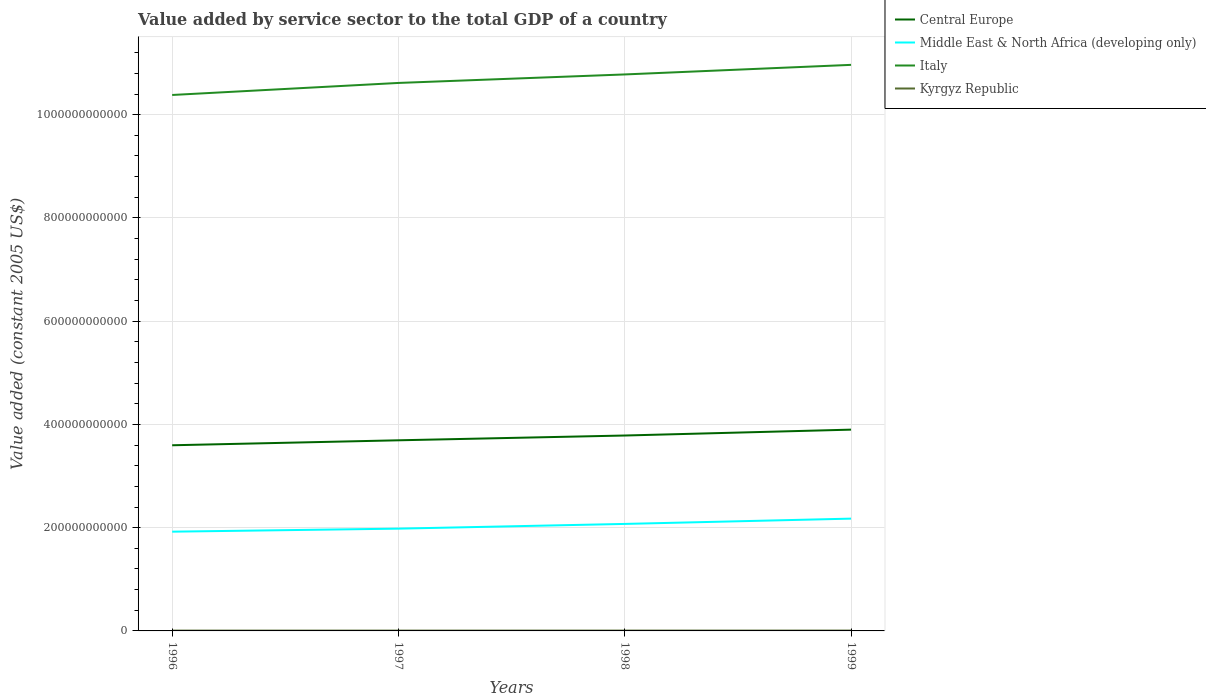Does the line corresponding to Middle East & North Africa (developing only) intersect with the line corresponding to Kyrgyz Republic?
Keep it short and to the point. No. Across all years, what is the maximum value added by service sector in Central Europe?
Keep it short and to the point. 3.60e+11. In which year was the value added by service sector in Italy maximum?
Provide a succinct answer. 1996. What is the total value added by service sector in Kyrgyz Republic in the graph?
Make the answer very short. -2.16e+07. What is the difference between the highest and the second highest value added by service sector in Kyrgyz Republic?
Your response must be concise. 4.91e+07. Is the value added by service sector in Italy strictly greater than the value added by service sector in Middle East & North Africa (developing only) over the years?
Provide a short and direct response. No. What is the difference between two consecutive major ticks on the Y-axis?
Provide a short and direct response. 2.00e+11. How many legend labels are there?
Keep it short and to the point. 4. How are the legend labels stacked?
Your answer should be compact. Vertical. What is the title of the graph?
Your answer should be very brief. Value added by service sector to the total GDP of a country. What is the label or title of the Y-axis?
Your answer should be very brief. Value added (constant 2005 US$). What is the Value added (constant 2005 US$) in Central Europe in 1996?
Your response must be concise. 3.60e+11. What is the Value added (constant 2005 US$) of Middle East & North Africa (developing only) in 1996?
Your answer should be compact. 1.92e+11. What is the Value added (constant 2005 US$) of Italy in 1996?
Provide a short and direct response. 1.04e+12. What is the Value added (constant 2005 US$) in Kyrgyz Republic in 1996?
Make the answer very short. 6.12e+08. What is the Value added (constant 2005 US$) of Central Europe in 1997?
Keep it short and to the point. 3.69e+11. What is the Value added (constant 2005 US$) in Middle East & North Africa (developing only) in 1997?
Your answer should be very brief. 1.98e+11. What is the Value added (constant 2005 US$) in Italy in 1997?
Your answer should be very brief. 1.06e+12. What is the Value added (constant 2005 US$) in Kyrgyz Republic in 1997?
Offer a very short reply. 6.16e+08. What is the Value added (constant 2005 US$) of Central Europe in 1998?
Your answer should be compact. 3.78e+11. What is the Value added (constant 2005 US$) in Middle East & North Africa (developing only) in 1998?
Your response must be concise. 2.07e+11. What is the Value added (constant 2005 US$) in Italy in 1998?
Offer a terse response. 1.08e+12. What is the Value added (constant 2005 US$) in Kyrgyz Republic in 1998?
Your answer should be compact. 6.40e+08. What is the Value added (constant 2005 US$) in Central Europe in 1999?
Make the answer very short. 3.90e+11. What is the Value added (constant 2005 US$) of Middle East & North Africa (developing only) in 1999?
Give a very brief answer. 2.18e+11. What is the Value added (constant 2005 US$) of Italy in 1999?
Offer a terse response. 1.10e+12. What is the Value added (constant 2005 US$) of Kyrgyz Republic in 1999?
Provide a short and direct response. 6.61e+08. Across all years, what is the maximum Value added (constant 2005 US$) of Central Europe?
Ensure brevity in your answer.  3.90e+11. Across all years, what is the maximum Value added (constant 2005 US$) of Middle East & North Africa (developing only)?
Offer a terse response. 2.18e+11. Across all years, what is the maximum Value added (constant 2005 US$) in Italy?
Give a very brief answer. 1.10e+12. Across all years, what is the maximum Value added (constant 2005 US$) in Kyrgyz Republic?
Make the answer very short. 6.61e+08. Across all years, what is the minimum Value added (constant 2005 US$) in Central Europe?
Your answer should be very brief. 3.60e+11. Across all years, what is the minimum Value added (constant 2005 US$) of Middle East & North Africa (developing only)?
Keep it short and to the point. 1.92e+11. Across all years, what is the minimum Value added (constant 2005 US$) in Italy?
Make the answer very short. 1.04e+12. Across all years, what is the minimum Value added (constant 2005 US$) of Kyrgyz Republic?
Provide a succinct answer. 6.12e+08. What is the total Value added (constant 2005 US$) in Central Europe in the graph?
Your response must be concise. 1.50e+12. What is the total Value added (constant 2005 US$) in Middle East & North Africa (developing only) in the graph?
Your answer should be compact. 8.15e+11. What is the total Value added (constant 2005 US$) in Italy in the graph?
Offer a terse response. 4.27e+12. What is the total Value added (constant 2005 US$) in Kyrgyz Republic in the graph?
Offer a terse response. 2.53e+09. What is the difference between the Value added (constant 2005 US$) in Central Europe in 1996 and that in 1997?
Provide a succinct answer. -9.62e+09. What is the difference between the Value added (constant 2005 US$) of Middle East & North Africa (developing only) in 1996 and that in 1997?
Your answer should be very brief. -5.87e+09. What is the difference between the Value added (constant 2005 US$) of Italy in 1996 and that in 1997?
Provide a succinct answer. -2.33e+1. What is the difference between the Value added (constant 2005 US$) in Kyrgyz Republic in 1996 and that in 1997?
Your response must be concise. -3.77e+06. What is the difference between the Value added (constant 2005 US$) of Central Europe in 1996 and that in 1998?
Offer a very short reply. -1.89e+1. What is the difference between the Value added (constant 2005 US$) in Middle East & North Africa (developing only) in 1996 and that in 1998?
Ensure brevity in your answer.  -1.50e+1. What is the difference between the Value added (constant 2005 US$) in Italy in 1996 and that in 1998?
Your response must be concise. -3.98e+1. What is the difference between the Value added (constant 2005 US$) of Kyrgyz Republic in 1996 and that in 1998?
Offer a terse response. -2.76e+07. What is the difference between the Value added (constant 2005 US$) in Central Europe in 1996 and that in 1999?
Provide a succinct answer. -3.02e+1. What is the difference between the Value added (constant 2005 US$) of Middle East & North Africa (developing only) in 1996 and that in 1999?
Make the answer very short. -2.52e+1. What is the difference between the Value added (constant 2005 US$) in Italy in 1996 and that in 1999?
Keep it short and to the point. -5.83e+1. What is the difference between the Value added (constant 2005 US$) in Kyrgyz Republic in 1996 and that in 1999?
Offer a terse response. -4.91e+07. What is the difference between the Value added (constant 2005 US$) of Central Europe in 1997 and that in 1998?
Your answer should be very brief. -9.24e+09. What is the difference between the Value added (constant 2005 US$) in Middle East & North Africa (developing only) in 1997 and that in 1998?
Offer a terse response. -9.13e+09. What is the difference between the Value added (constant 2005 US$) of Italy in 1997 and that in 1998?
Offer a terse response. -1.65e+1. What is the difference between the Value added (constant 2005 US$) in Kyrgyz Republic in 1997 and that in 1998?
Keep it short and to the point. -2.38e+07. What is the difference between the Value added (constant 2005 US$) of Central Europe in 1997 and that in 1999?
Provide a short and direct response. -2.06e+1. What is the difference between the Value added (constant 2005 US$) of Middle East & North Africa (developing only) in 1997 and that in 1999?
Your response must be concise. -1.94e+1. What is the difference between the Value added (constant 2005 US$) of Italy in 1997 and that in 1999?
Give a very brief answer. -3.50e+1. What is the difference between the Value added (constant 2005 US$) in Kyrgyz Republic in 1997 and that in 1999?
Provide a short and direct response. -4.54e+07. What is the difference between the Value added (constant 2005 US$) of Central Europe in 1998 and that in 1999?
Keep it short and to the point. -1.14e+1. What is the difference between the Value added (constant 2005 US$) of Middle East & North Africa (developing only) in 1998 and that in 1999?
Offer a very short reply. -1.03e+1. What is the difference between the Value added (constant 2005 US$) of Italy in 1998 and that in 1999?
Offer a very short reply. -1.85e+1. What is the difference between the Value added (constant 2005 US$) in Kyrgyz Republic in 1998 and that in 1999?
Offer a very short reply. -2.16e+07. What is the difference between the Value added (constant 2005 US$) of Central Europe in 1996 and the Value added (constant 2005 US$) of Middle East & North Africa (developing only) in 1997?
Offer a terse response. 1.61e+11. What is the difference between the Value added (constant 2005 US$) in Central Europe in 1996 and the Value added (constant 2005 US$) in Italy in 1997?
Your answer should be compact. -7.02e+11. What is the difference between the Value added (constant 2005 US$) of Central Europe in 1996 and the Value added (constant 2005 US$) of Kyrgyz Republic in 1997?
Provide a succinct answer. 3.59e+11. What is the difference between the Value added (constant 2005 US$) in Middle East & North Africa (developing only) in 1996 and the Value added (constant 2005 US$) in Italy in 1997?
Ensure brevity in your answer.  -8.69e+11. What is the difference between the Value added (constant 2005 US$) of Middle East & North Africa (developing only) in 1996 and the Value added (constant 2005 US$) of Kyrgyz Republic in 1997?
Make the answer very short. 1.92e+11. What is the difference between the Value added (constant 2005 US$) in Italy in 1996 and the Value added (constant 2005 US$) in Kyrgyz Republic in 1997?
Provide a succinct answer. 1.04e+12. What is the difference between the Value added (constant 2005 US$) of Central Europe in 1996 and the Value added (constant 2005 US$) of Middle East & North Africa (developing only) in 1998?
Your answer should be very brief. 1.52e+11. What is the difference between the Value added (constant 2005 US$) in Central Europe in 1996 and the Value added (constant 2005 US$) in Italy in 1998?
Make the answer very short. -7.18e+11. What is the difference between the Value added (constant 2005 US$) of Central Europe in 1996 and the Value added (constant 2005 US$) of Kyrgyz Republic in 1998?
Provide a short and direct response. 3.59e+11. What is the difference between the Value added (constant 2005 US$) of Middle East & North Africa (developing only) in 1996 and the Value added (constant 2005 US$) of Italy in 1998?
Provide a short and direct response. -8.86e+11. What is the difference between the Value added (constant 2005 US$) in Middle East & North Africa (developing only) in 1996 and the Value added (constant 2005 US$) in Kyrgyz Republic in 1998?
Give a very brief answer. 1.92e+11. What is the difference between the Value added (constant 2005 US$) of Italy in 1996 and the Value added (constant 2005 US$) of Kyrgyz Republic in 1998?
Your answer should be compact. 1.04e+12. What is the difference between the Value added (constant 2005 US$) of Central Europe in 1996 and the Value added (constant 2005 US$) of Middle East & North Africa (developing only) in 1999?
Make the answer very short. 1.42e+11. What is the difference between the Value added (constant 2005 US$) in Central Europe in 1996 and the Value added (constant 2005 US$) in Italy in 1999?
Make the answer very short. -7.37e+11. What is the difference between the Value added (constant 2005 US$) in Central Europe in 1996 and the Value added (constant 2005 US$) in Kyrgyz Republic in 1999?
Your answer should be compact. 3.59e+11. What is the difference between the Value added (constant 2005 US$) of Middle East & North Africa (developing only) in 1996 and the Value added (constant 2005 US$) of Italy in 1999?
Make the answer very short. -9.04e+11. What is the difference between the Value added (constant 2005 US$) of Middle East & North Africa (developing only) in 1996 and the Value added (constant 2005 US$) of Kyrgyz Republic in 1999?
Your answer should be very brief. 1.92e+11. What is the difference between the Value added (constant 2005 US$) in Italy in 1996 and the Value added (constant 2005 US$) in Kyrgyz Republic in 1999?
Your answer should be very brief. 1.04e+12. What is the difference between the Value added (constant 2005 US$) in Central Europe in 1997 and the Value added (constant 2005 US$) in Middle East & North Africa (developing only) in 1998?
Keep it short and to the point. 1.62e+11. What is the difference between the Value added (constant 2005 US$) in Central Europe in 1997 and the Value added (constant 2005 US$) in Italy in 1998?
Offer a very short reply. -7.09e+11. What is the difference between the Value added (constant 2005 US$) in Central Europe in 1997 and the Value added (constant 2005 US$) in Kyrgyz Republic in 1998?
Your response must be concise. 3.69e+11. What is the difference between the Value added (constant 2005 US$) of Middle East & North Africa (developing only) in 1997 and the Value added (constant 2005 US$) of Italy in 1998?
Your answer should be very brief. -8.80e+11. What is the difference between the Value added (constant 2005 US$) in Middle East & North Africa (developing only) in 1997 and the Value added (constant 2005 US$) in Kyrgyz Republic in 1998?
Ensure brevity in your answer.  1.97e+11. What is the difference between the Value added (constant 2005 US$) of Italy in 1997 and the Value added (constant 2005 US$) of Kyrgyz Republic in 1998?
Your answer should be very brief. 1.06e+12. What is the difference between the Value added (constant 2005 US$) in Central Europe in 1997 and the Value added (constant 2005 US$) in Middle East & North Africa (developing only) in 1999?
Ensure brevity in your answer.  1.52e+11. What is the difference between the Value added (constant 2005 US$) in Central Europe in 1997 and the Value added (constant 2005 US$) in Italy in 1999?
Ensure brevity in your answer.  -7.27e+11. What is the difference between the Value added (constant 2005 US$) in Central Europe in 1997 and the Value added (constant 2005 US$) in Kyrgyz Republic in 1999?
Your response must be concise. 3.69e+11. What is the difference between the Value added (constant 2005 US$) in Middle East & North Africa (developing only) in 1997 and the Value added (constant 2005 US$) in Italy in 1999?
Offer a terse response. -8.98e+11. What is the difference between the Value added (constant 2005 US$) in Middle East & North Africa (developing only) in 1997 and the Value added (constant 2005 US$) in Kyrgyz Republic in 1999?
Your answer should be very brief. 1.97e+11. What is the difference between the Value added (constant 2005 US$) in Italy in 1997 and the Value added (constant 2005 US$) in Kyrgyz Republic in 1999?
Your response must be concise. 1.06e+12. What is the difference between the Value added (constant 2005 US$) of Central Europe in 1998 and the Value added (constant 2005 US$) of Middle East & North Africa (developing only) in 1999?
Provide a succinct answer. 1.61e+11. What is the difference between the Value added (constant 2005 US$) in Central Europe in 1998 and the Value added (constant 2005 US$) in Italy in 1999?
Ensure brevity in your answer.  -7.18e+11. What is the difference between the Value added (constant 2005 US$) of Central Europe in 1998 and the Value added (constant 2005 US$) of Kyrgyz Republic in 1999?
Give a very brief answer. 3.78e+11. What is the difference between the Value added (constant 2005 US$) of Middle East & North Africa (developing only) in 1998 and the Value added (constant 2005 US$) of Italy in 1999?
Your answer should be compact. -8.89e+11. What is the difference between the Value added (constant 2005 US$) of Middle East & North Africa (developing only) in 1998 and the Value added (constant 2005 US$) of Kyrgyz Republic in 1999?
Provide a short and direct response. 2.07e+11. What is the difference between the Value added (constant 2005 US$) of Italy in 1998 and the Value added (constant 2005 US$) of Kyrgyz Republic in 1999?
Give a very brief answer. 1.08e+12. What is the average Value added (constant 2005 US$) in Central Europe per year?
Make the answer very short. 3.74e+11. What is the average Value added (constant 2005 US$) in Middle East & North Africa (developing only) per year?
Provide a short and direct response. 2.04e+11. What is the average Value added (constant 2005 US$) of Italy per year?
Offer a very short reply. 1.07e+12. What is the average Value added (constant 2005 US$) in Kyrgyz Republic per year?
Your answer should be compact. 6.32e+08. In the year 1996, what is the difference between the Value added (constant 2005 US$) of Central Europe and Value added (constant 2005 US$) of Middle East & North Africa (developing only)?
Your answer should be very brief. 1.67e+11. In the year 1996, what is the difference between the Value added (constant 2005 US$) of Central Europe and Value added (constant 2005 US$) of Italy?
Your response must be concise. -6.78e+11. In the year 1996, what is the difference between the Value added (constant 2005 US$) of Central Europe and Value added (constant 2005 US$) of Kyrgyz Republic?
Your answer should be compact. 3.59e+11. In the year 1996, what is the difference between the Value added (constant 2005 US$) of Middle East & North Africa (developing only) and Value added (constant 2005 US$) of Italy?
Your answer should be compact. -8.46e+11. In the year 1996, what is the difference between the Value added (constant 2005 US$) in Middle East & North Africa (developing only) and Value added (constant 2005 US$) in Kyrgyz Republic?
Offer a terse response. 1.92e+11. In the year 1996, what is the difference between the Value added (constant 2005 US$) of Italy and Value added (constant 2005 US$) of Kyrgyz Republic?
Make the answer very short. 1.04e+12. In the year 1997, what is the difference between the Value added (constant 2005 US$) of Central Europe and Value added (constant 2005 US$) of Middle East & North Africa (developing only)?
Offer a terse response. 1.71e+11. In the year 1997, what is the difference between the Value added (constant 2005 US$) of Central Europe and Value added (constant 2005 US$) of Italy?
Make the answer very short. -6.92e+11. In the year 1997, what is the difference between the Value added (constant 2005 US$) of Central Europe and Value added (constant 2005 US$) of Kyrgyz Republic?
Make the answer very short. 3.69e+11. In the year 1997, what is the difference between the Value added (constant 2005 US$) of Middle East & North Africa (developing only) and Value added (constant 2005 US$) of Italy?
Keep it short and to the point. -8.63e+11. In the year 1997, what is the difference between the Value added (constant 2005 US$) in Middle East & North Africa (developing only) and Value added (constant 2005 US$) in Kyrgyz Republic?
Give a very brief answer. 1.98e+11. In the year 1997, what is the difference between the Value added (constant 2005 US$) of Italy and Value added (constant 2005 US$) of Kyrgyz Republic?
Provide a short and direct response. 1.06e+12. In the year 1998, what is the difference between the Value added (constant 2005 US$) in Central Europe and Value added (constant 2005 US$) in Middle East & North Africa (developing only)?
Your answer should be very brief. 1.71e+11. In the year 1998, what is the difference between the Value added (constant 2005 US$) of Central Europe and Value added (constant 2005 US$) of Italy?
Ensure brevity in your answer.  -6.99e+11. In the year 1998, what is the difference between the Value added (constant 2005 US$) in Central Europe and Value added (constant 2005 US$) in Kyrgyz Republic?
Your answer should be very brief. 3.78e+11. In the year 1998, what is the difference between the Value added (constant 2005 US$) in Middle East & North Africa (developing only) and Value added (constant 2005 US$) in Italy?
Your answer should be compact. -8.71e+11. In the year 1998, what is the difference between the Value added (constant 2005 US$) in Middle East & North Africa (developing only) and Value added (constant 2005 US$) in Kyrgyz Republic?
Keep it short and to the point. 2.07e+11. In the year 1998, what is the difference between the Value added (constant 2005 US$) of Italy and Value added (constant 2005 US$) of Kyrgyz Republic?
Keep it short and to the point. 1.08e+12. In the year 1999, what is the difference between the Value added (constant 2005 US$) of Central Europe and Value added (constant 2005 US$) of Middle East & North Africa (developing only)?
Your answer should be compact. 1.72e+11. In the year 1999, what is the difference between the Value added (constant 2005 US$) in Central Europe and Value added (constant 2005 US$) in Italy?
Ensure brevity in your answer.  -7.07e+11. In the year 1999, what is the difference between the Value added (constant 2005 US$) of Central Europe and Value added (constant 2005 US$) of Kyrgyz Republic?
Offer a terse response. 3.89e+11. In the year 1999, what is the difference between the Value added (constant 2005 US$) in Middle East & North Africa (developing only) and Value added (constant 2005 US$) in Italy?
Offer a terse response. -8.79e+11. In the year 1999, what is the difference between the Value added (constant 2005 US$) of Middle East & North Africa (developing only) and Value added (constant 2005 US$) of Kyrgyz Republic?
Offer a terse response. 2.17e+11. In the year 1999, what is the difference between the Value added (constant 2005 US$) of Italy and Value added (constant 2005 US$) of Kyrgyz Republic?
Offer a very short reply. 1.10e+12. What is the ratio of the Value added (constant 2005 US$) of Central Europe in 1996 to that in 1997?
Your response must be concise. 0.97. What is the ratio of the Value added (constant 2005 US$) of Middle East & North Africa (developing only) in 1996 to that in 1997?
Provide a succinct answer. 0.97. What is the ratio of the Value added (constant 2005 US$) of Italy in 1996 to that in 1997?
Keep it short and to the point. 0.98. What is the ratio of the Value added (constant 2005 US$) of Central Europe in 1996 to that in 1998?
Give a very brief answer. 0.95. What is the ratio of the Value added (constant 2005 US$) in Middle East & North Africa (developing only) in 1996 to that in 1998?
Your answer should be very brief. 0.93. What is the ratio of the Value added (constant 2005 US$) in Italy in 1996 to that in 1998?
Your response must be concise. 0.96. What is the ratio of the Value added (constant 2005 US$) in Kyrgyz Republic in 1996 to that in 1998?
Your answer should be compact. 0.96. What is the ratio of the Value added (constant 2005 US$) in Central Europe in 1996 to that in 1999?
Your answer should be compact. 0.92. What is the ratio of the Value added (constant 2005 US$) in Middle East & North Africa (developing only) in 1996 to that in 1999?
Your answer should be compact. 0.88. What is the ratio of the Value added (constant 2005 US$) in Italy in 1996 to that in 1999?
Your response must be concise. 0.95. What is the ratio of the Value added (constant 2005 US$) of Kyrgyz Republic in 1996 to that in 1999?
Offer a very short reply. 0.93. What is the ratio of the Value added (constant 2005 US$) of Central Europe in 1997 to that in 1998?
Keep it short and to the point. 0.98. What is the ratio of the Value added (constant 2005 US$) in Middle East & North Africa (developing only) in 1997 to that in 1998?
Your response must be concise. 0.96. What is the ratio of the Value added (constant 2005 US$) in Italy in 1997 to that in 1998?
Provide a succinct answer. 0.98. What is the ratio of the Value added (constant 2005 US$) of Kyrgyz Republic in 1997 to that in 1998?
Make the answer very short. 0.96. What is the ratio of the Value added (constant 2005 US$) of Central Europe in 1997 to that in 1999?
Provide a succinct answer. 0.95. What is the ratio of the Value added (constant 2005 US$) in Middle East & North Africa (developing only) in 1997 to that in 1999?
Provide a short and direct response. 0.91. What is the ratio of the Value added (constant 2005 US$) in Italy in 1997 to that in 1999?
Your answer should be very brief. 0.97. What is the ratio of the Value added (constant 2005 US$) in Kyrgyz Republic in 1997 to that in 1999?
Provide a succinct answer. 0.93. What is the ratio of the Value added (constant 2005 US$) in Central Europe in 1998 to that in 1999?
Keep it short and to the point. 0.97. What is the ratio of the Value added (constant 2005 US$) of Middle East & North Africa (developing only) in 1998 to that in 1999?
Give a very brief answer. 0.95. What is the ratio of the Value added (constant 2005 US$) in Italy in 1998 to that in 1999?
Provide a succinct answer. 0.98. What is the ratio of the Value added (constant 2005 US$) in Kyrgyz Republic in 1998 to that in 1999?
Your answer should be very brief. 0.97. What is the difference between the highest and the second highest Value added (constant 2005 US$) in Central Europe?
Your answer should be very brief. 1.14e+1. What is the difference between the highest and the second highest Value added (constant 2005 US$) of Middle East & North Africa (developing only)?
Give a very brief answer. 1.03e+1. What is the difference between the highest and the second highest Value added (constant 2005 US$) in Italy?
Keep it short and to the point. 1.85e+1. What is the difference between the highest and the second highest Value added (constant 2005 US$) of Kyrgyz Republic?
Your response must be concise. 2.16e+07. What is the difference between the highest and the lowest Value added (constant 2005 US$) in Central Europe?
Provide a succinct answer. 3.02e+1. What is the difference between the highest and the lowest Value added (constant 2005 US$) in Middle East & North Africa (developing only)?
Your response must be concise. 2.52e+1. What is the difference between the highest and the lowest Value added (constant 2005 US$) in Italy?
Offer a very short reply. 5.83e+1. What is the difference between the highest and the lowest Value added (constant 2005 US$) of Kyrgyz Republic?
Ensure brevity in your answer.  4.91e+07. 